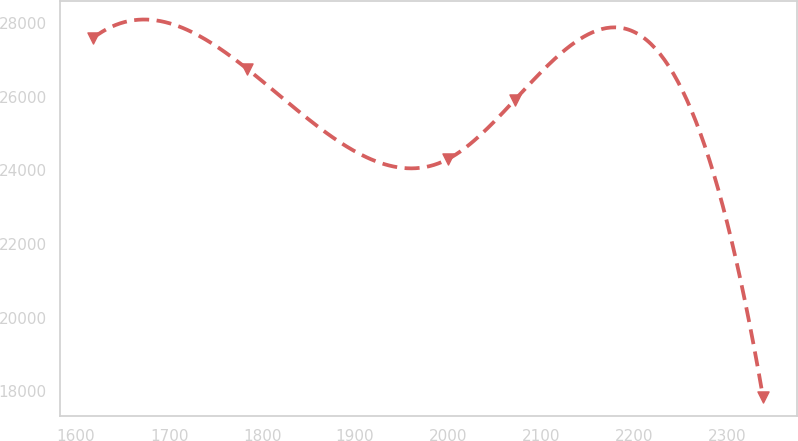Convert chart to OTSL. <chart><loc_0><loc_0><loc_500><loc_500><line_chart><ecel><fcel>Unnamed: 1<nl><fcel>1618.55<fcel>27605.2<nl><fcel>1783.99<fcel>26758.7<nl><fcel>1999.53<fcel>24303.8<nl><fcel>2071.53<fcel>25912.2<nl><fcel>2338.58<fcel>17836.2<nl></chart> 